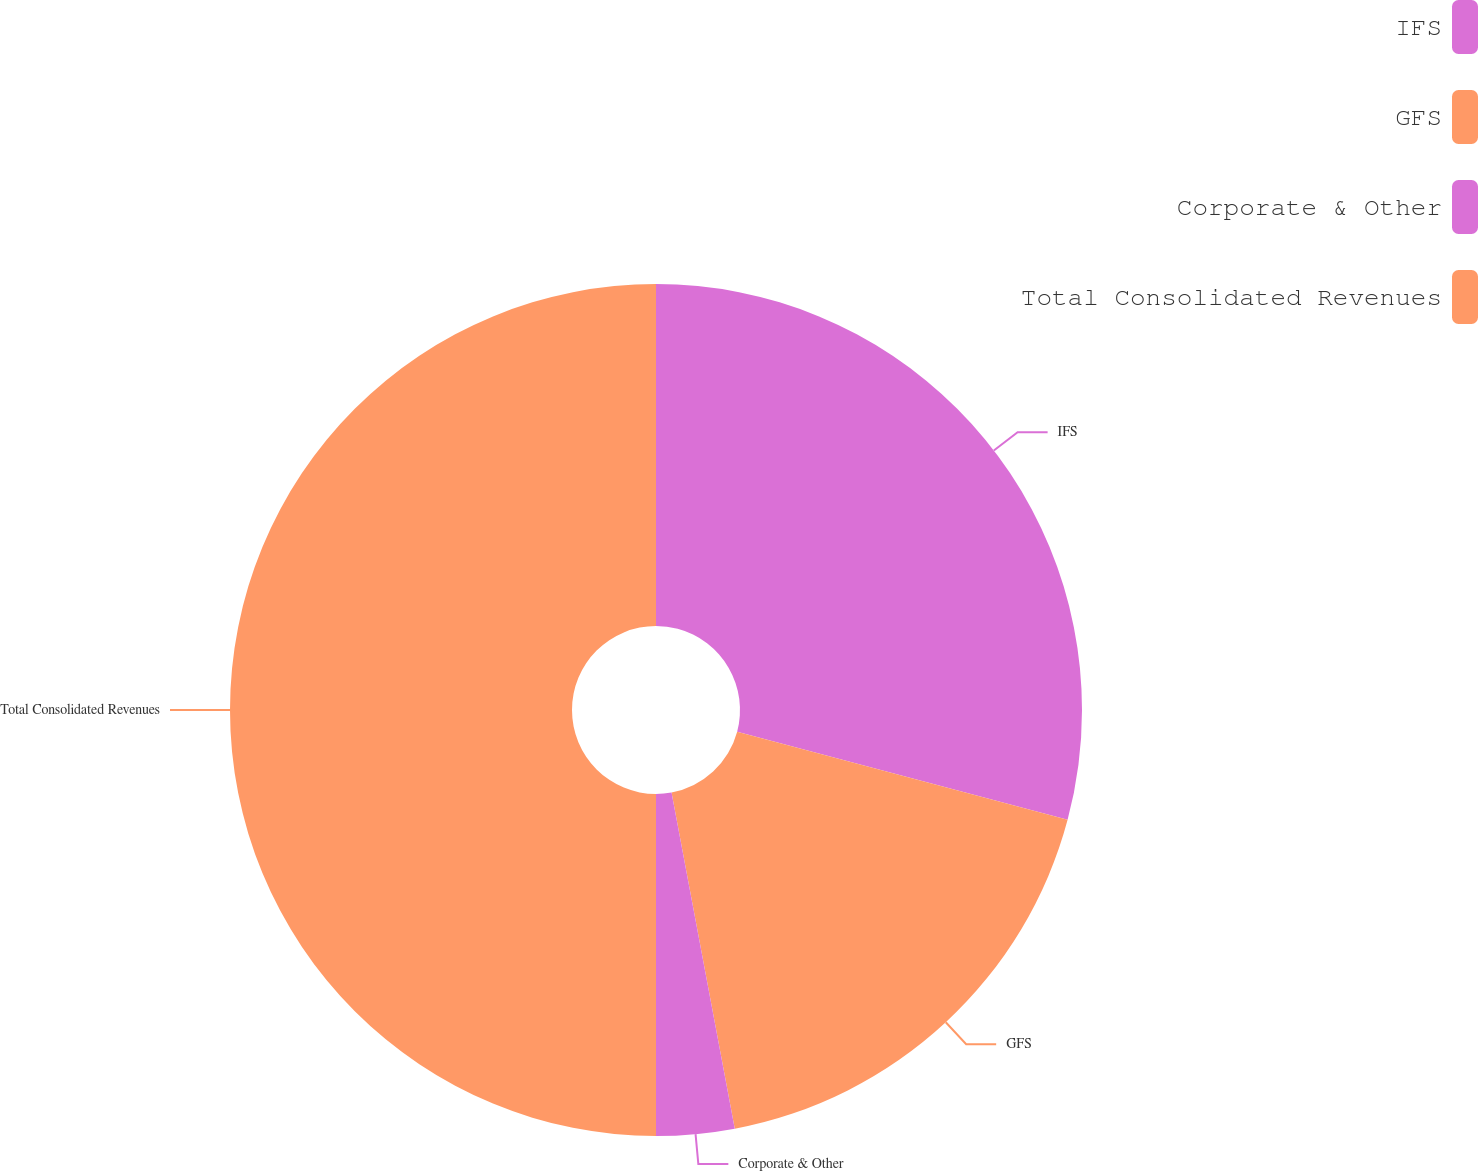Convert chart. <chart><loc_0><loc_0><loc_500><loc_500><pie_chart><fcel>IFS<fcel>GFS<fcel>Corporate & Other<fcel>Total Consolidated Revenues<nl><fcel>29.15%<fcel>17.89%<fcel>2.96%<fcel>50.0%<nl></chart> 